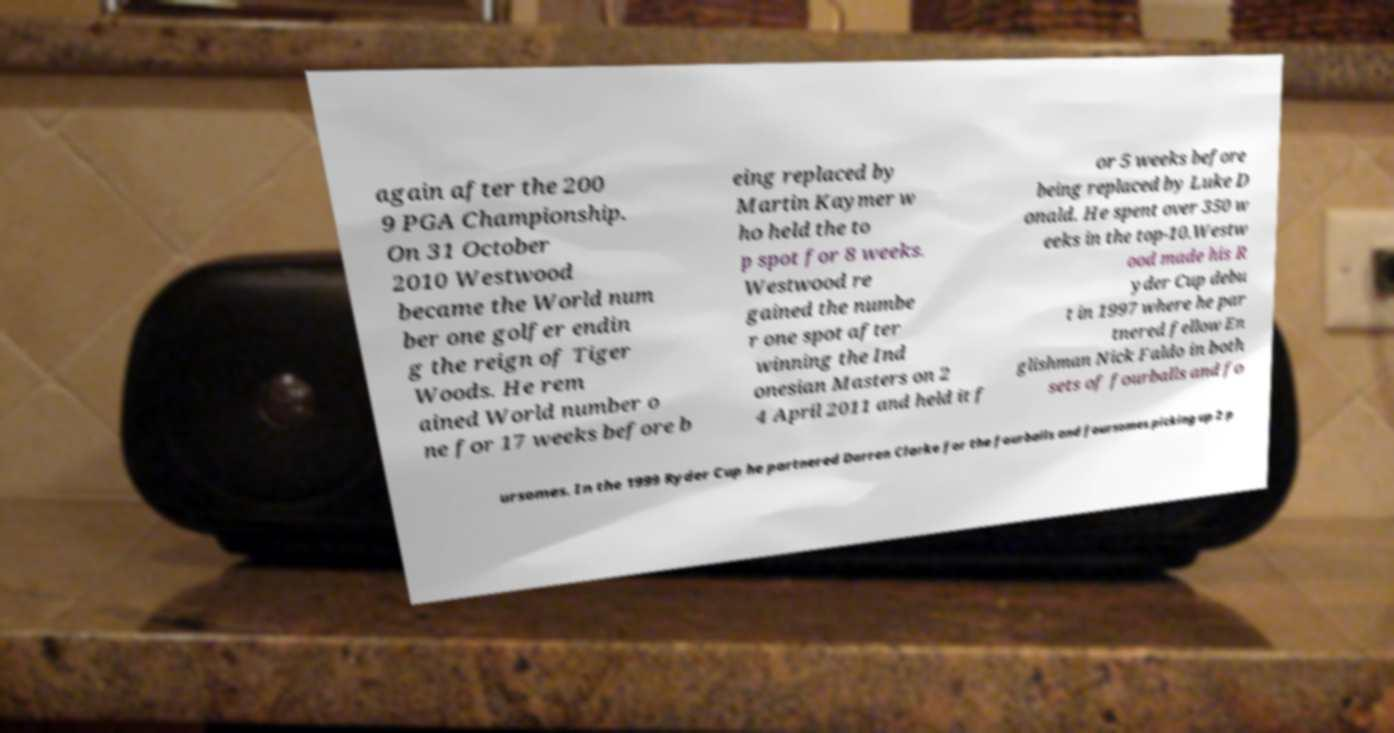Could you extract and type out the text from this image? again after the 200 9 PGA Championship. On 31 October 2010 Westwood became the World num ber one golfer endin g the reign of Tiger Woods. He rem ained World number o ne for 17 weeks before b eing replaced by Martin Kaymer w ho held the to p spot for 8 weeks. Westwood re gained the numbe r one spot after winning the Ind onesian Masters on 2 4 April 2011 and held it f or 5 weeks before being replaced by Luke D onald. He spent over 350 w eeks in the top-10.Westw ood made his R yder Cup debu t in 1997 where he par tnered fellow En glishman Nick Faldo in both sets of fourballs and fo ursomes. In the 1999 Ryder Cup he partnered Darren Clarke for the fourballs and foursomes picking up 2 p 